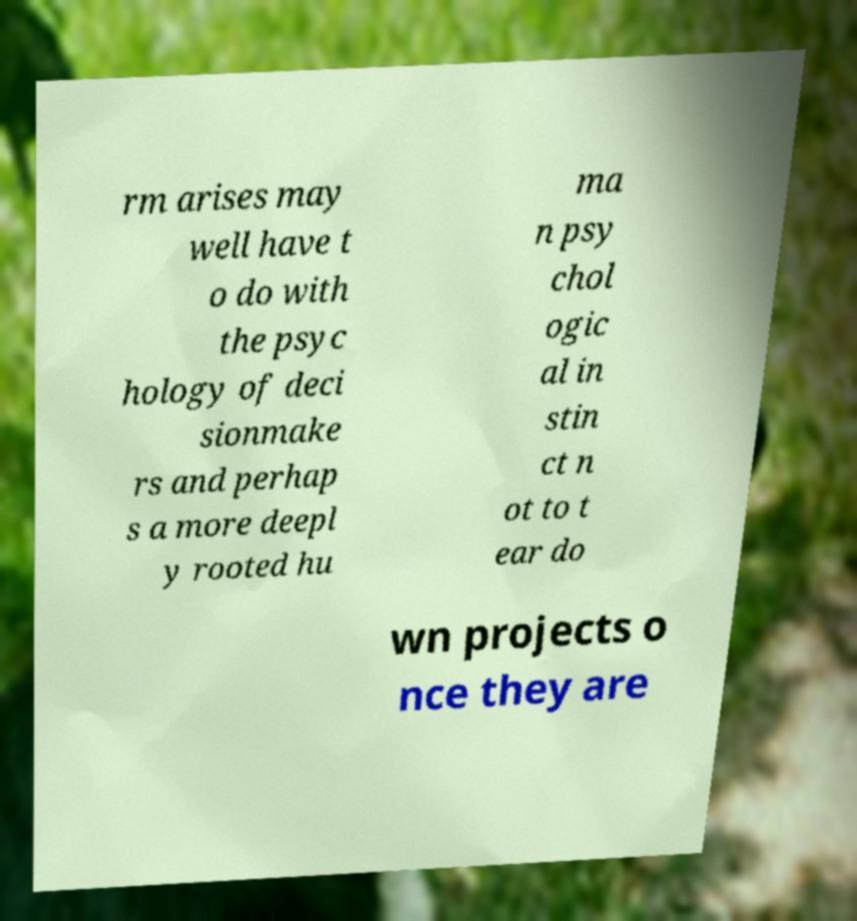Can you accurately transcribe the text from the provided image for me? rm arises may well have t o do with the psyc hology of deci sionmake rs and perhap s a more deepl y rooted hu ma n psy chol ogic al in stin ct n ot to t ear do wn projects o nce they are 